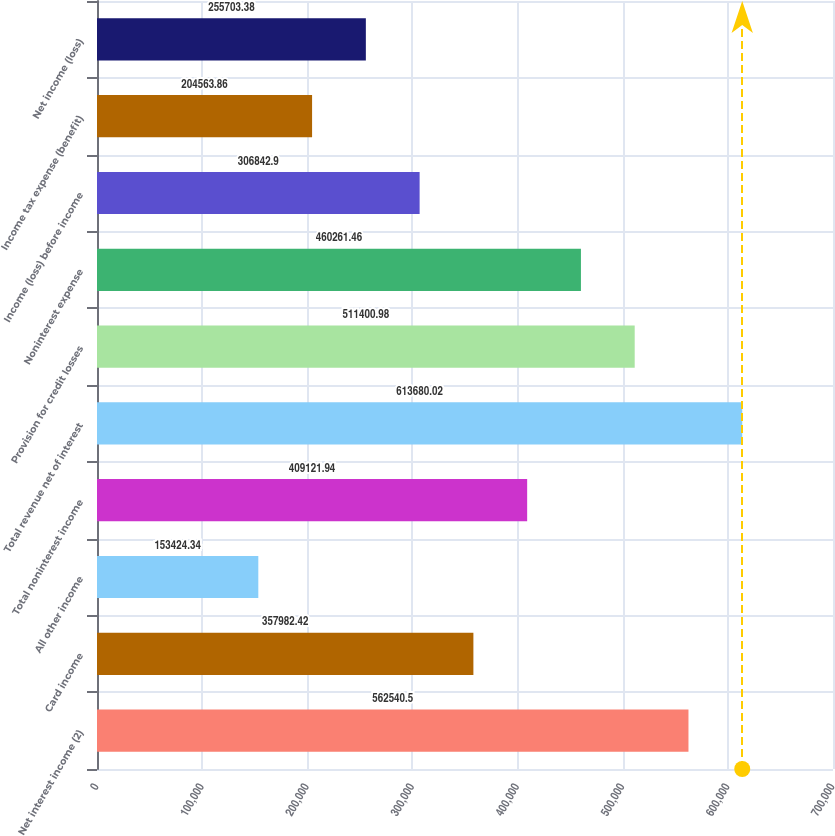<chart> <loc_0><loc_0><loc_500><loc_500><bar_chart><fcel>Net interest income (2)<fcel>Card income<fcel>All other income<fcel>Total noninterest income<fcel>Total revenue net of interest<fcel>Provision for credit losses<fcel>Noninterest expense<fcel>Income (loss) before income<fcel>Income tax expense (benefit)<fcel>Net income (loss)<nl><fcel>562540<fcel>357982<fcel>153424<fcel>409122<fcel>613680<fcel>511401<fcel>460261<fcel>306843<fcel>204564<fcel>255703<nl></chart> 